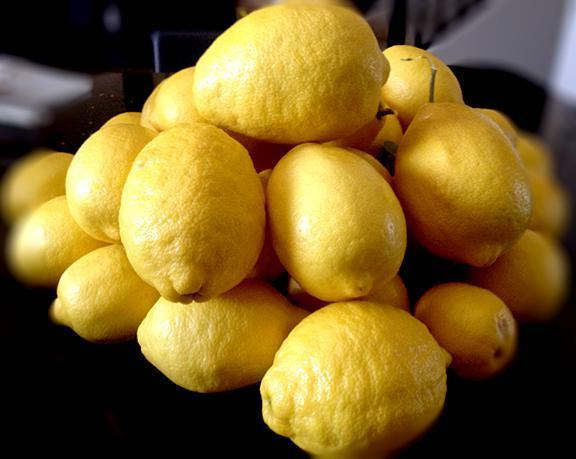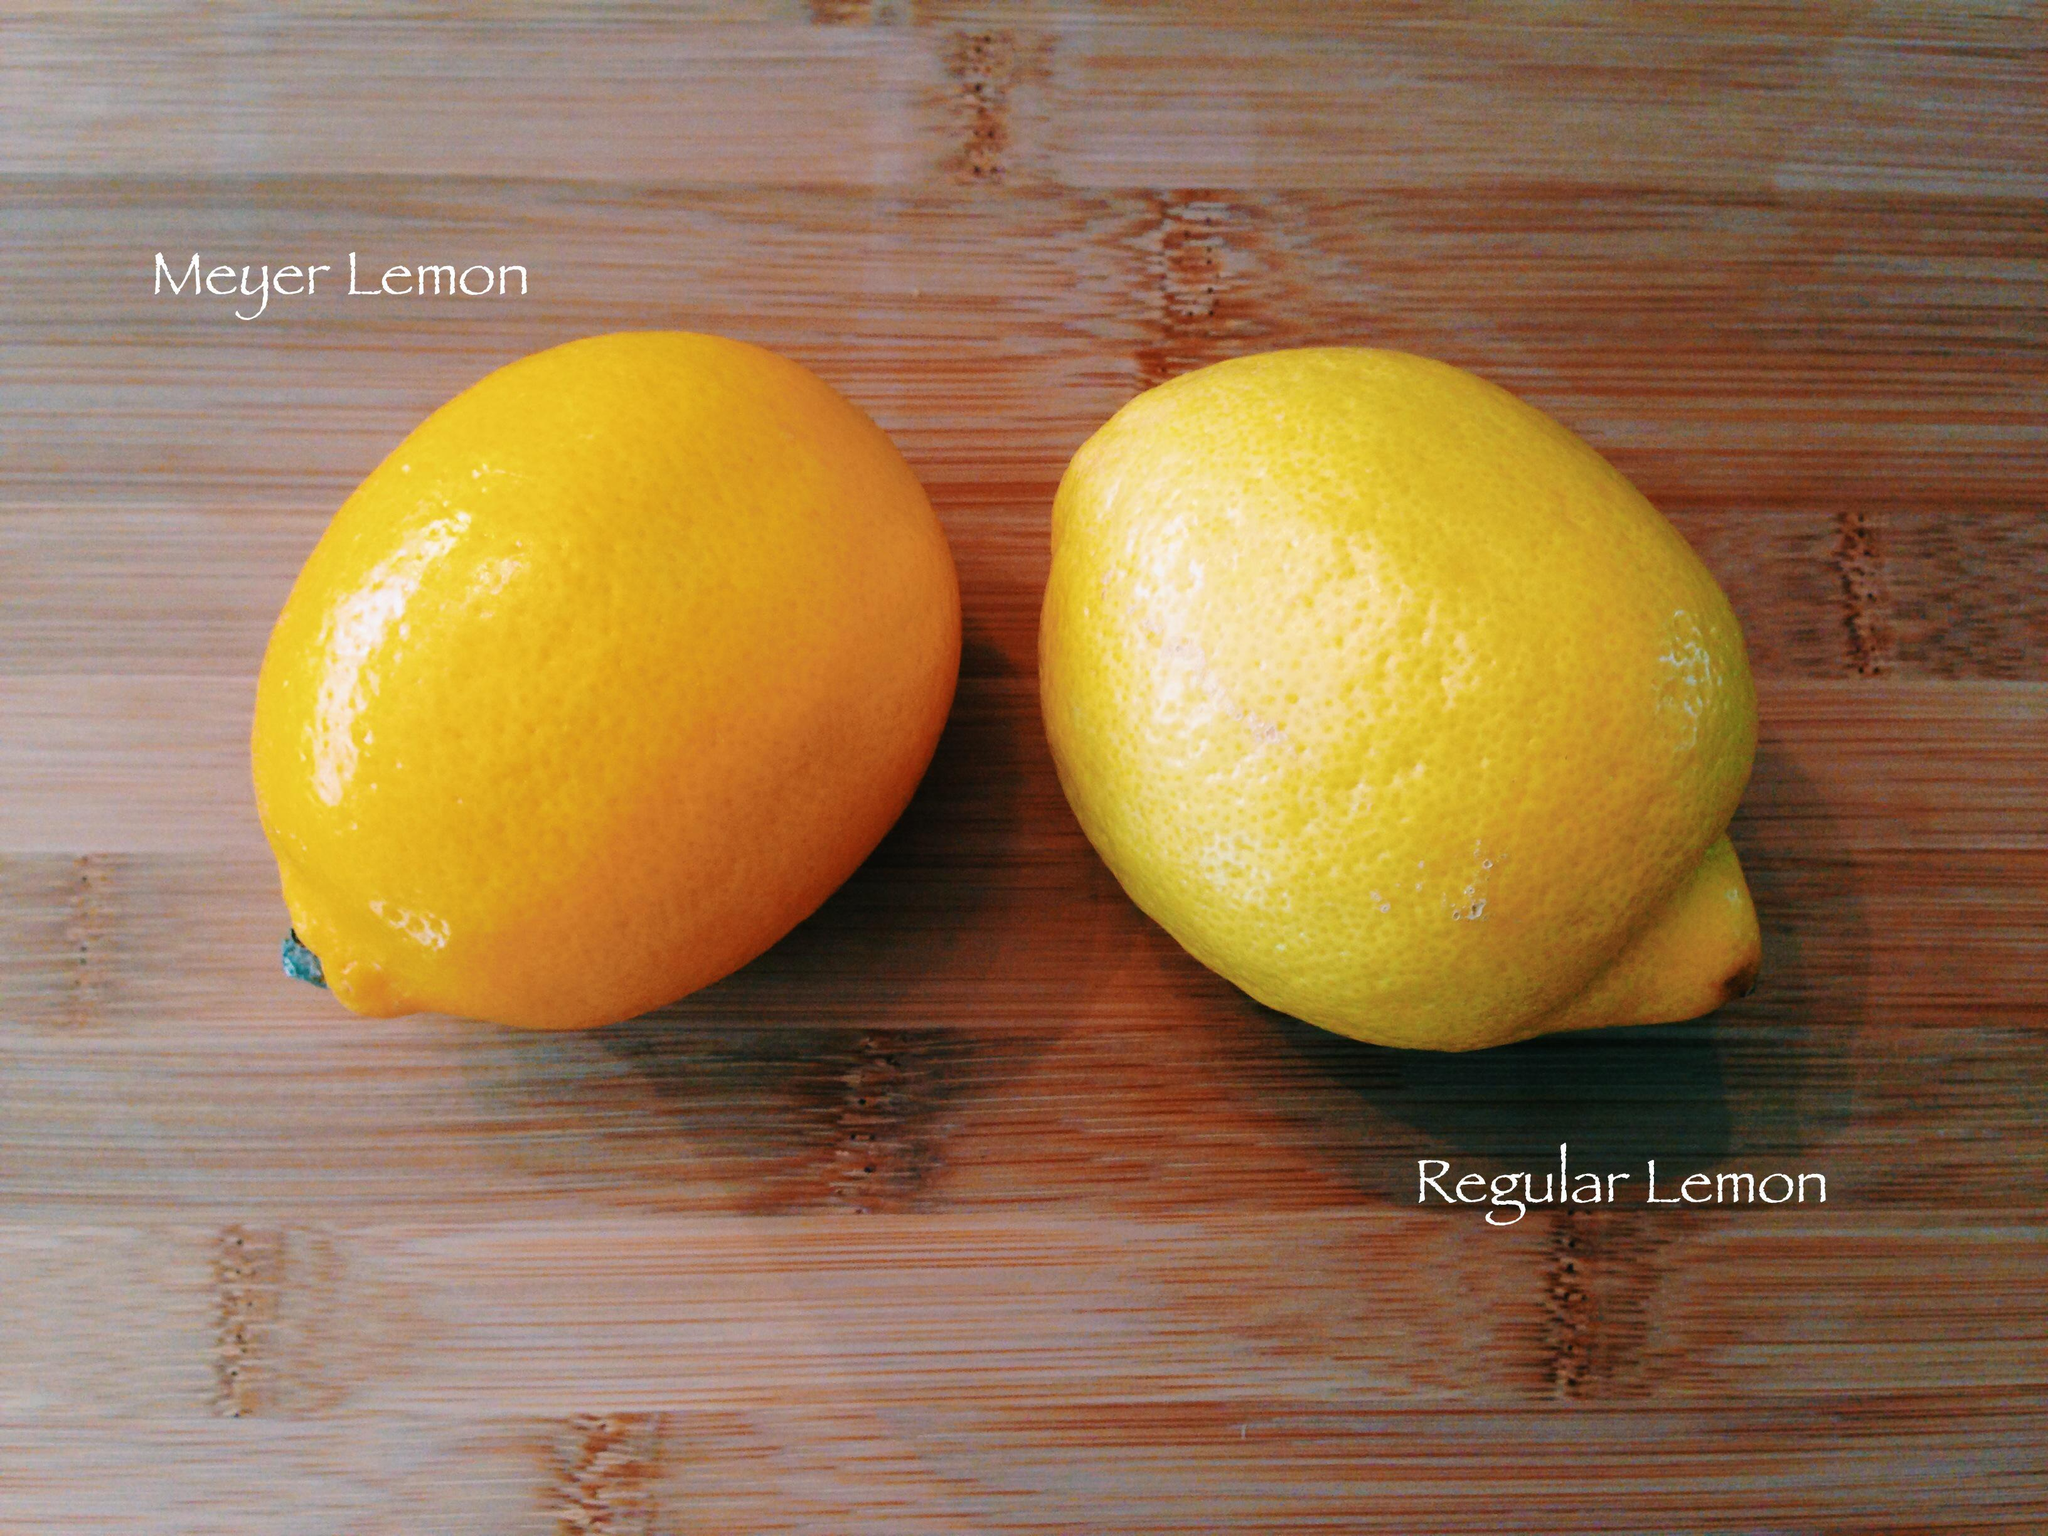The first image is the image on the left, the second image is the image on the right. Analyze the images presented: Is the assertion "All of the fruit is whole and is not on a tree." valid? Answer yes or no. Yes. The first image is the image on the left, the second image is the image on the right. Analyze the images presented: Is the assertion "None of the lemons in the images have been sliced open." valid? Answer yes or no. Yes. 